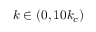Convert formula to latex. <formula><loc_0><loc_0><loc_500><loc_500>k \in ( 0 , 1 0 k _ { c } )</formula> 